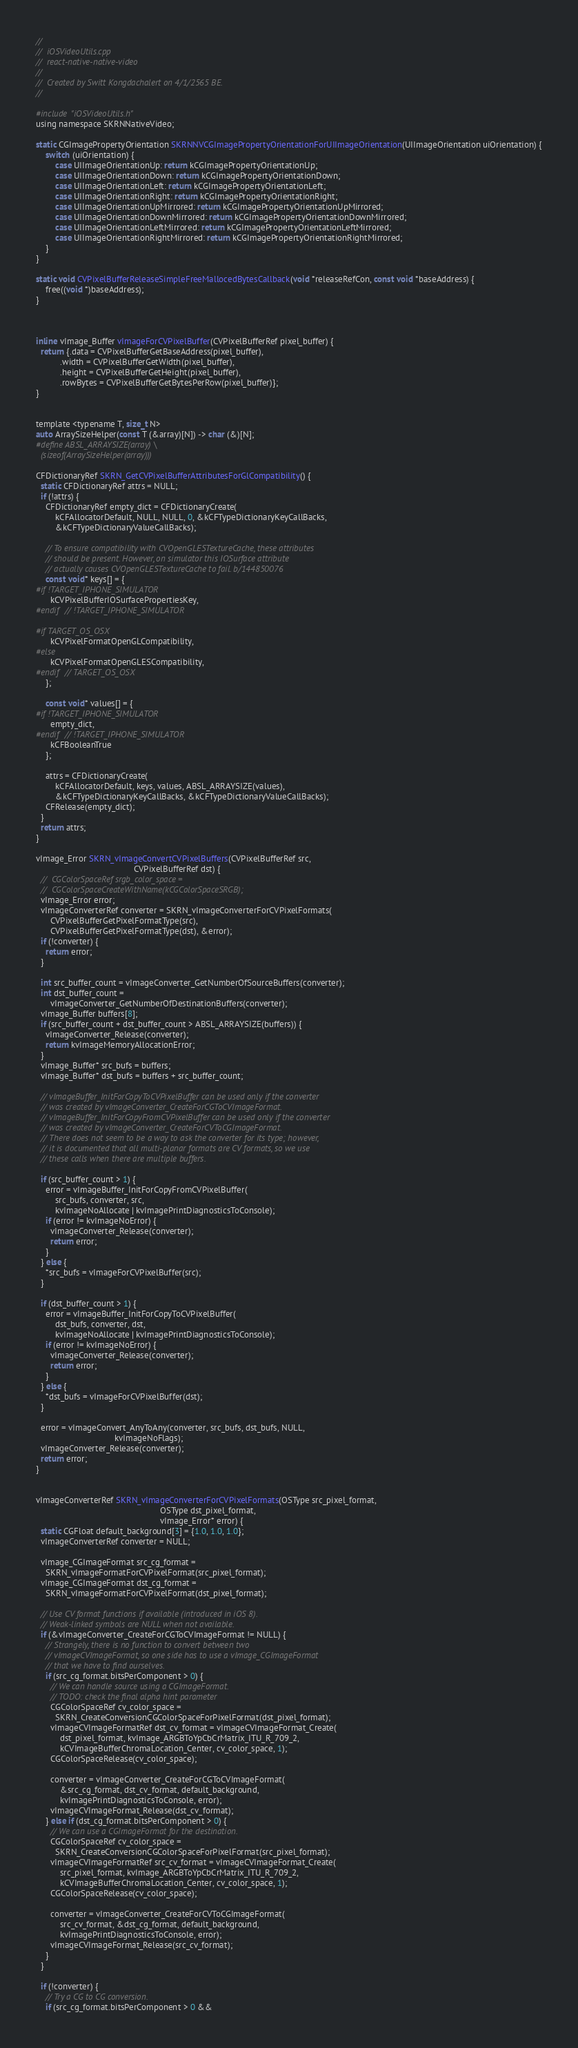<code> <loc_0><loc_0><loc_500><loc_500><_ObjectiveC_>//
//  iOSVideoUtils.cpp
//  react-native-native-video
//
//  Created by Switt Kongdachalert on 4/1/2565 BE.
//

#include "iOSVideoUtils.h"
using namespace SKRNNativeVideo;

static CGImagePropertyOrientation SKRNNVCGImagePropertyOrientationForUIImageOrientation(UIImageOrientation uiOrientation) {
    switch (uiOrientation) {
        case UIImageOrientationUp: return kCGImagePropertyOrientationUp;
        case UIImageOrientationDown: return kCGImagePropertyOrientationDown;
        case UIImageOrientationLeft: return kCGImagePropertyOrientationLeft;
        case UIImageOrientationRight: return kCGImagePropertyOrientationRight;
        case UIImageOrientationUpMirrored: return kCGImagePropertyOrientationUpMirrored;
        case UIImageOrientationDownMirrored: return kCGImagePropertyOrientationDownMirrored;
        case UIImageOrientationLeftMirrored: return kCGImagePropertyOrientationLeftMirrored;
        case UIImageOrientationRightMirrored: return kCGImagePropertyOrientationRightMirrored;
    }
}

static void CVPixelBufferReleaseSimpleFreeMallocedBytesCallback(void *releaseRefCon, const void *baseAddress) {
    free((void *)baseAddress);
}



inline vImage_Buffer vImageForCVPixelBuffer(CVPixelBufferRef pixel_buffer) {
  return {.data = CVPixelBufferGetBaseAddress(pixel_buffer),
          .width = CVPixelBufferGetWidth(pixel_buffer),
          .height = CVPixelBufferGetHeight(pixel_buffer),
          .rowBytes = CVPixelBufferGetBytesPerRow(pixel_buffer)};
}


template <typename T, size_t N>
auto ArraySizeHelper(const T (&array)[N]) -> char (&)[N];
#define ABSL_ARRAYSIZE(array) \
  (sizeof(ArraySizeHelper(array)))

CFDictionaryRef SKRN_GetCVPixelBufferAttributesForGlCompatibility() {
  static CFDictionaryRef attrs = NULL;
  if (!attrs) {
    CFDictionaryRef empty_dict = CFDictionaryCreate(
        kCFAllocatorDefault, NULL, NULL, 0, &kCFTypeDictionaryKeyCallBacks,
        &kCFTypeDictionaryValueCallBacks);

    // To ensure compatibility with CVOpenGLESTextureCache, these attributes
    // should be present. However, on simulator this IOSurface attribute
    // actually causes CVOpenGLESTextureCache to fail. b/144850076
    const void* keys[] = {
#if !TARGET_IPHONE_SIMULATOR
      kCVPixelBufferIOSurfacePropertiesKey,
#endif  // !TARGET_IPHONE_SIMULATOR

#if TARGET_OS_OSX
      kCVPixelFormatOpenGLCompatibility,
#else
      kCVPixelFormatOpenGLESCompatibility,
#endif  // TARGET_OS_OSX
    };

    const void* values[] = {
#if !TARGET_IPHONE_SIMULATOR
      empty_dict,
#endif  // !TARGET_IPHONE_SIMULATOR
      kCFBooleanTrue
    };

    attrs = CFDictionaryCreate(
        kCFAllocatorDefault, keys, values, ABSL_ARRAYSIZE(values),
        &kCFTypeDictionaryKeyCallBacks, &kCFTypeDictionaryValueCallBacks);
    CFRelease(empty_dict);
  }
  return attrs;
}

vImage_Error SKRN_vImageConvertCVPixelBuffers(CVPixelBufferRef src,
                                         CVPixelBufferRef dst) {
  //  CGColorSpaceRef srgb_color_space =
  //  CGColorSpaceCreateWithName(kCGColorSpaceSRGB);
  vImage_Error error;
  vImageConverterRef converter = SKRN_vImageConverterForCVPixelFormats(
      CVPixelBufferGetPixelFormatType(src),
      CVPixelBufferGetPixelFormatType(dst), &error);
  if (!converter) {
    return error;
  }

  int src_buffer_count = vImageConverter_GetNumberOfSourceBuffers(converter);
  int dst_buffer_count =
      vImageConverter_GetNumberOfDestinationBuffers(converter);
  vImage_Buffer buffers[8];
  if (src_buffer_count + dst_buffer_count > ABSL_ARRAYSIZE(buffers)) {
    vImageConverter_Release(converter);
    return kvImageMemoryAllocationError;
  }
  vImage_Buffer* src_bufs = buffers;
  vImage_Buffer* dst_bufs = buffers + src_buffer_count;

  // vImageBuffer_InitForCopyToCVPixelBuffer can be used only if the converter
  // was created by vImageConverter_CreateForCGToCVImageFormat.
  // vImageBuffer_InitForCopyFromCVPixelBuffer can be used only if the converter
  // was created by vImageConverter_CreateForCVToCGImageFormat.
  // There does not seem to be a way to ask the converter for its type; however,
  // it is documented that all multi-planar formats are CV formats, so we use
  // these calls when there are multiple buffers.

  if (src_buffer_count > 1) {
    error = vImageBuffer_InitForCopyFromCVPixelBuffer(
        src_bufs, converter, src,
        kvImageNoAllocate | kvImagePrintDiagnosticsToConsole);
    if (error != kvImageNoError) {
      vImageConverter_Release(converter);
      return error;
    }
  } else {
    *src_bufs = vImageForCVPixelBuffer(src);
  }

  if (dst_buffer_count > 1) {
    error = vImageBuffer_InitForCopyToCVPixelBuffer(
        dst_bufs, converter, dst,
        kvImageNoAllocate | kvImagePrintDiagnosticsToConsole);
    if (error != kvImageNoError) {
      vImageConverter_Release(converter);
      return error;
    }
  } else {
    *dst_bufs = vImageForCVPixelBuffer(dst);
  }

  error = vImageConvert_AnyToAny(converter, src_bufs, dst_bufs, NULL,
                                 kvImageNoFlags);
  vImageConverter_Release(converter);
  return error;
}


vImageConverterRef SKRN_vImageConverterForCVPixelFormats(OSType src_pixel_format,
                                                    OSType dst_pixel_format,
                                                    vImage_Error* error) {
  static CGFloat default_background[3] = {1.0, 1.0, 1.0};
  vImageConverterRef converter = NULL;

  vImage_CGImageFormat src_cg_format =
    SKRN_vImageFormatForCVPixelFormat(src_pixel_format);
  vImage_CGImageFormat dst_cg_format =
    SKRN_vImageFormatForCVPixelFormat(dst_pixel_format);

  // Use CV format functions if available (introduced in iOS 8).
  // Weak-linked symbols are NULL when not available.
  if (&vImageConverter_CreateForCGToCVImageFormat != NULL) {
    // Strangely, there is no function to convert between two
    // vImageCVImageFormat, so one side has to use a vImage_CGImageFormat
    // that we have to find ourselves.
    if (src_cg_format.bitsPerComponent > 0) {
      // We can handle source using a CGImageFormat.
      // TODO: check the final alpha hint parameter
      CGColorSpaceRef cv_color_space =
        SKRN_CreateConversionCGColorSpaceForPixelFormat(dst_pixel_format);
      vImageCVImageFormatRef dst_cv_format = vImageCVImageFormat_Create(
          dst_pixel_format, kvImage_ARGBToYpCbCrMatrix_ITU_R_709_2,
          kCVImageBufferChromaLocation_Center, cv_color_space, 1);
      CGColorSpaceRelease(cv_color_space);

      converter = vImageConverter_CreateForCGToCVImageFormat(
          &src_cg_format, dst_cv_format, default_background,
          kvImagePrintDiagnosticsToConsole, error);
      vImageCVImageFormat_Release(dst_cv_format);
    } else if (dst_cg_format.bitsPerComponent > 0) {
      // We can use a CGImageFormat for the destination.
      CGColorSpaceRef cv_color_space =
        SKRN_CreateConversionCGColorSpaceForPixelFormat(src_pixel_format);
      vImageCVImageFormatRef src_cv_format = vImageCVImageFormat_Create(
          src_pixel_format, kvImage_ARGBToYpCbCrMatrix_ITU_R_709_2,
          kCVImageBufferChromaLocation_Center, cv_color_space, 1);
      CGColorSpaceRelease(cv_color_space);

      converter = vImageConverter_CreateForCVToCGImageFormat(
          src_cv_format, &dst_cg_format, default_background,
          kvImagePrintDiagnosticsToConsole, error);
      vImageCVImageFormat_Release(src_cv_format);
    }
  }

  if (!converter) {
    // Try a CG to CG conversion.
    if (src_cg_format.bitsPerComponent > 0 &&</code> 